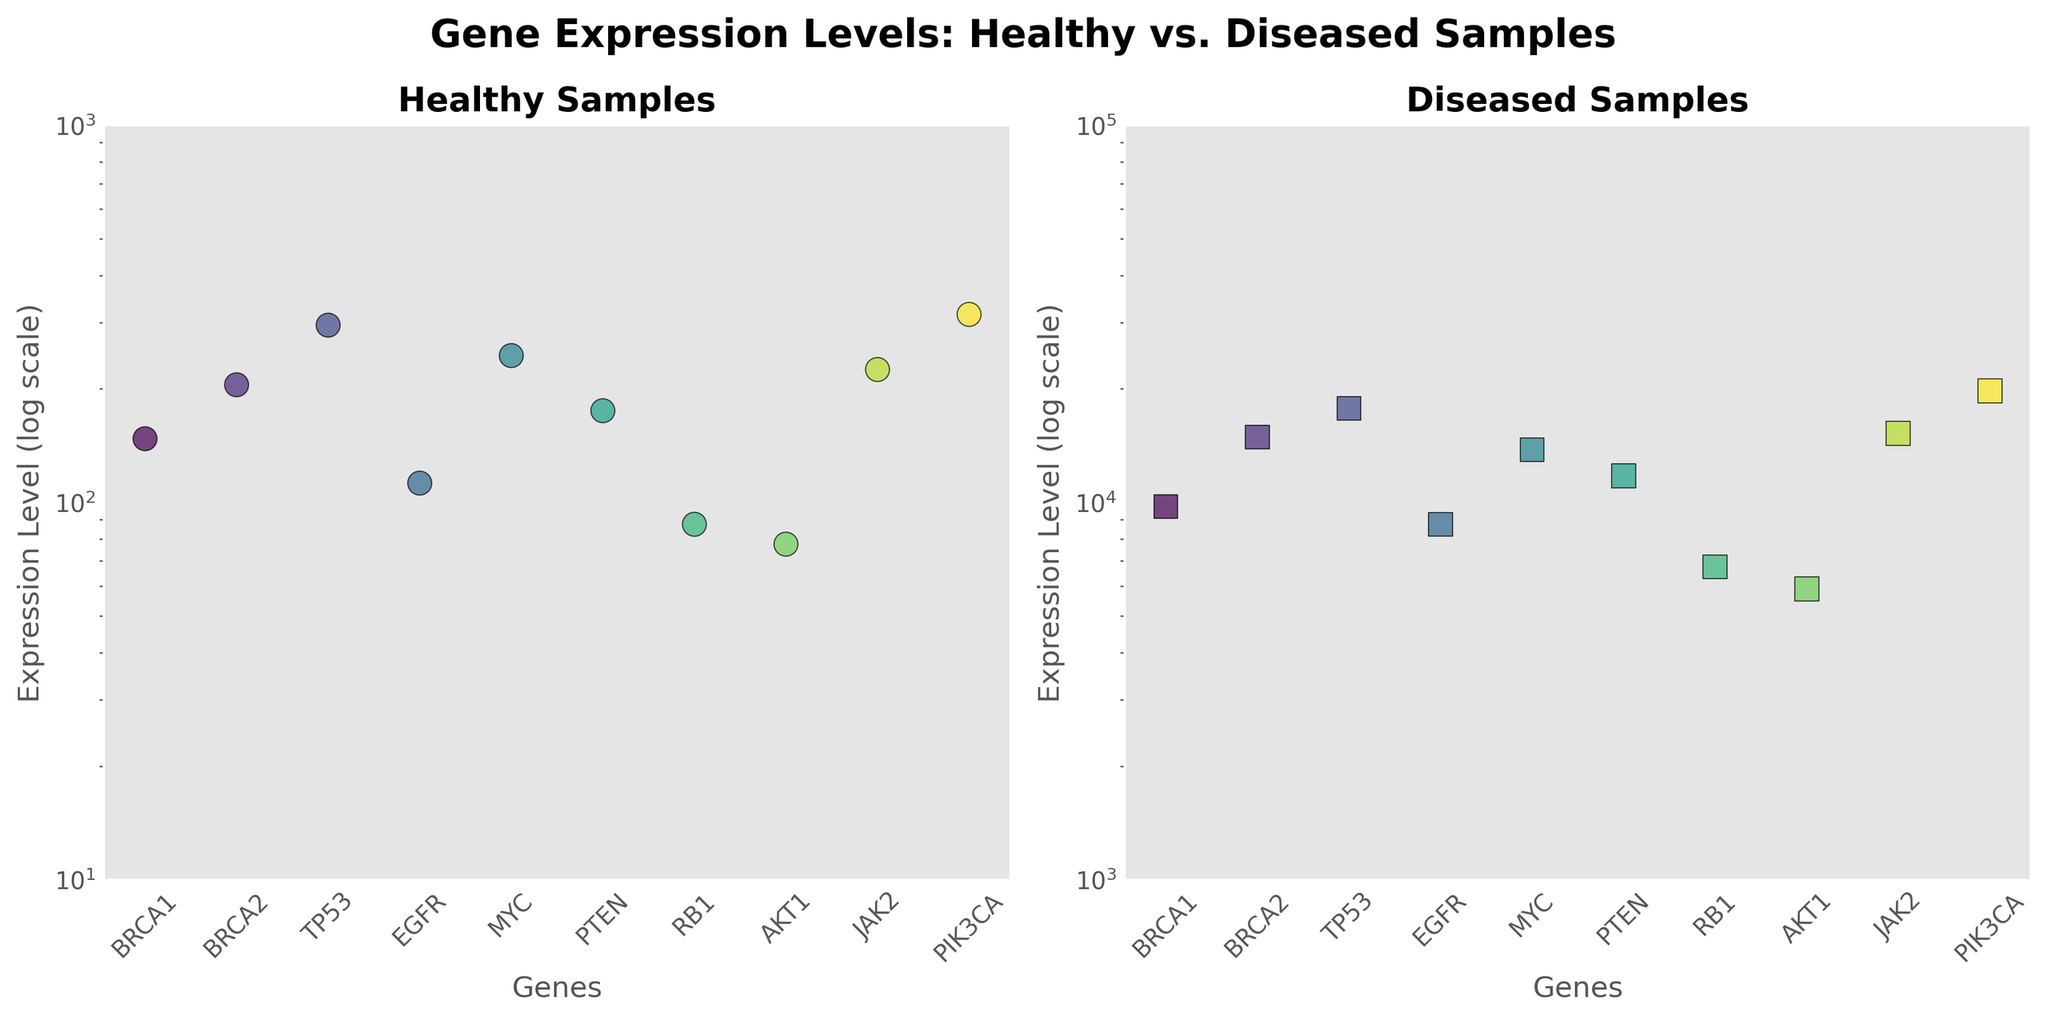How many genes are displayed in each subplot? Both subplots display scatter plots of gene expression levels for multiple genes. Counting the data points in either subplot, we see that there are 10 different genes represented in each subplot.
Answer: 10 What are the average expression levels of the BRCA1 gene in healthy and diseased samples? In the healthy subplot, the BRCA1 gene has an average expression level calculated as (150 + 145) / 2 = 147.5. In the diseased subplot, it is (10000 + 9500) / 2 = 9750.
Answer: 147.5 and 9750 Which gene shows the highest average expression in diseased samples? By examining the scatter plot of the diseased samples, the highest data point is for the PIK3CA gene. This is evident by its position near the upper end of the log scale.
Answer: PIK3CA Is the difference in average expression levels between healthy and diseased samples for TP53 greater than that for RB1? For TP53, the difference in average expression levels is 17750 - 295 = 17455. For RB1, it is 6750 - 87.5 = 6662.5. Since 17455 > 6662.5, the difference is indeed greater for TP53.
Answer: Yes What is the range of expression levels in healthy samples on the log scale axis? Looking at the y-axis in the healthy samples subplot, the smallest and largest average expression levels correspond to data points positioned near the lower (around 75, log scale) and upper (around 320, log scale) parts of the axis. Therefore, the range can be approximately calculated as 75 to 320.
Answer: 75 to 320 Between the healthy and diseased samples, which gene shows the largest increase in expression level? To find the largest increase, calculate the difference for each gene between diseased and healthy averages. The largest difference is for the PIK3CA gene with an increase from around 315 to 19750 (approx. 19485).
Answer: PIK3CA Which subplot has a wider range of expression levels on the log scale? Comparing the two subplots, the healthy samples range from about 75 to 320, while the diseased samples range from about 6000 to 20000. The diseased subplot thus has a wider range of expression levels.
Answer: Diseased samples subplot Are all the average expression levels higher in diseased samples compared to healthy samples for the gene MYC? In the healthy subplot, MYC has an average expression level of (250 + 240) / 2 = 245. In the diseased subplot, it has (14000 + 13600) / 2 = 13800. Since 13800 is greater than 245, the average expression levels are indeed higher in diseased samples.
Answer: Yes Is the average expression level of BRCA2 in the healthy samples closer to that of TP53 or JAK2? For BRCA2, the average in healthy samples is (200 + 210) / 2 = 205. For TP53, it is (300 + 290) / 2 = 295. For JAK2, it is (220 + 230) / 2 = 225. Since 205 is closer to 225 than it is to 295, the average expression level of BRCA2 is closer to that of JAK2.
Answer: JAK2 Which gene has the lowest expression level in healthy samples, and what is its average? Examining the scatter plot of healthy samples, the gene with the lowest position on the y-axis is AKT1. Its average expression level is calculated as (75 + 80) / 2 = 77.5.
Answer: AKT1, 77.5 